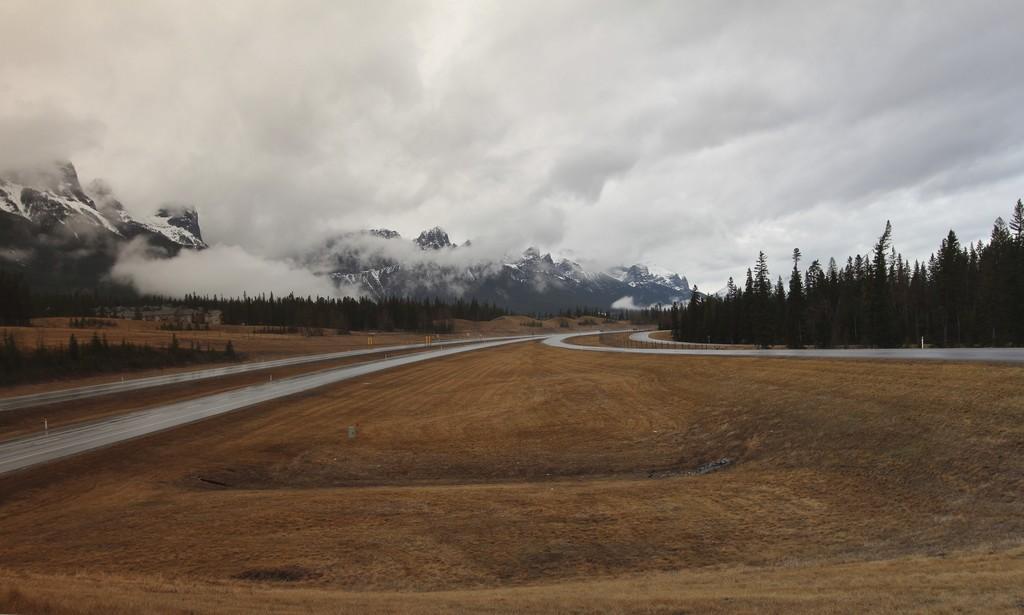Please provide a concise description of this image. In this image I can see the ground and road. To the side of the road there is a railing and many trees. In the back there are mountains, fog and the sky. 